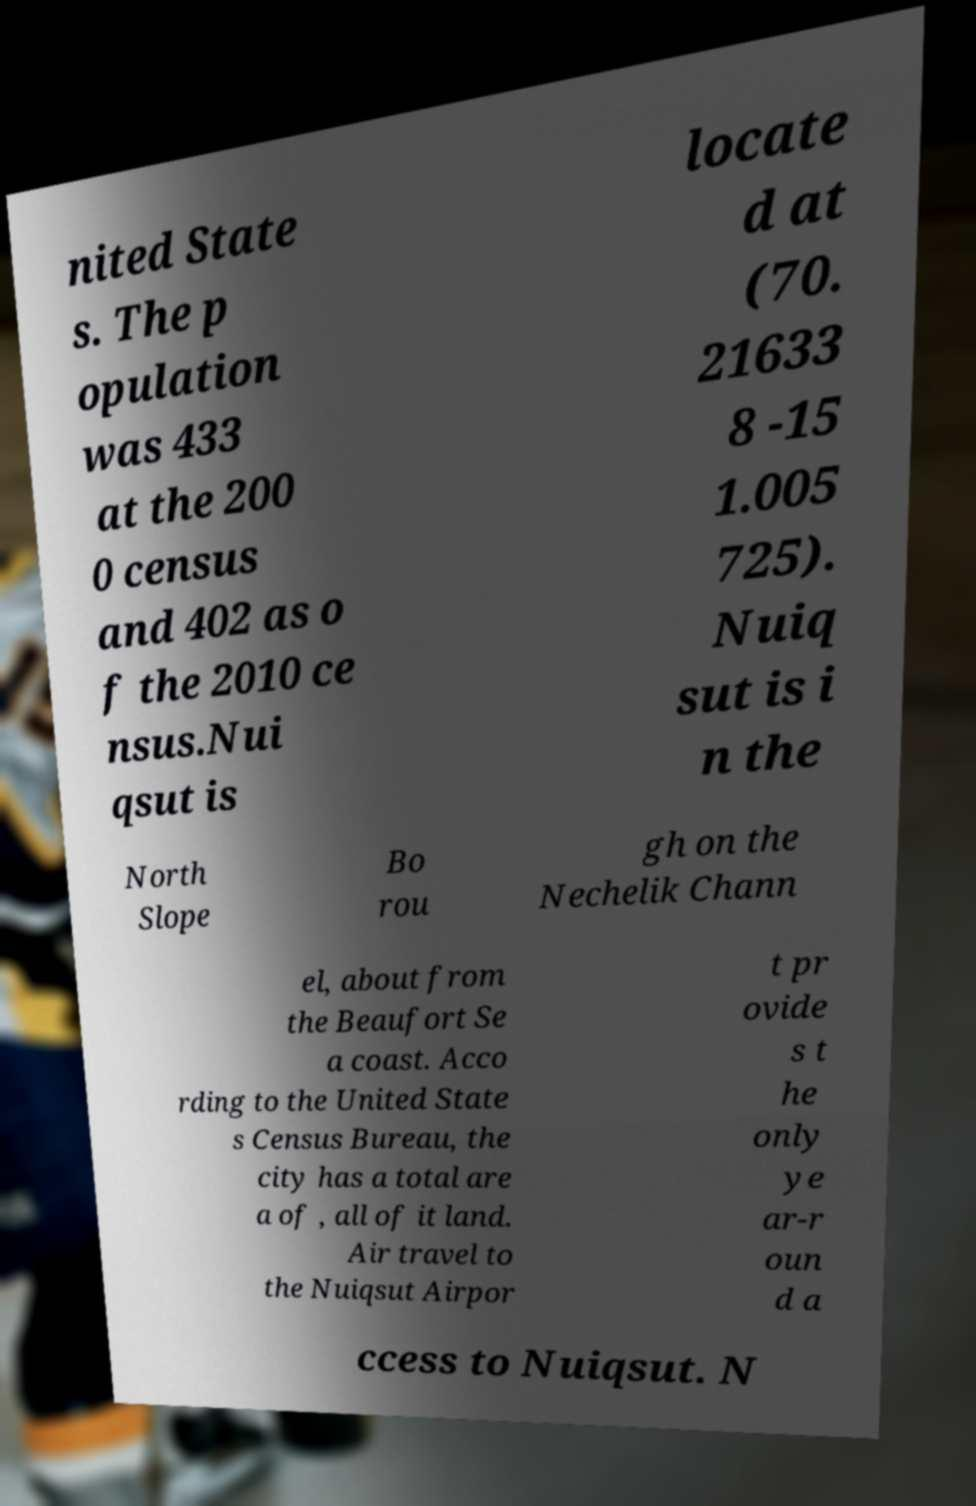Could you extract and type out the text from this image? nited State s. The p opulation was 433 at the 200 0 census and 402 as o f the 2010 ce nsus.Nui qsut is locate d at (70. 21633 8 -15 1.005 725). Nuiq sut is i n the North Slope Bo rou gh on the Nechelik Chann el, about from the Beaufort Se a coast. Acco rding to the United State s Census Bureau, the city has a total are a of , all of it land. Air travel to the Nuiqsut Airpor t pr ovide s t he only ye ar-r oun d a ccess to Nuiqsut. N 